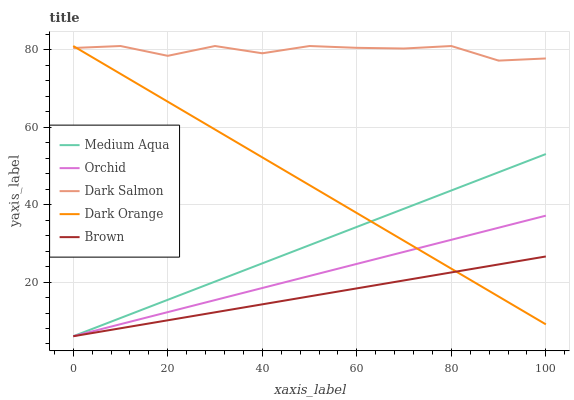Does Brown have the minimum area under the curve?
Answer yes or no. Yes. Does Dark Salmon have the maximum area under the curve?
Answer yes or no. Yes. Does Medium Aqua have the minimum area under the curve?
Answer yes or no. No. Does Medium Aqua have the maximum area under the curve?
Answer yes or no. No. Is Brown the smoothest?
Answer yes or no. Yes. Is Dark Salmon the roughest?
Answer yes or no. Yes. Is Medium Aqua the smoothest?
Answer yes or no. No. Is Medium Aqua the roughest?
Answer yes or no. No. Does Medium Aqua have the lowest value?
Answer yes or no. Yes. Does Dark Salmon have the lowest value?
Answer yes or no. No. Does Dark Salmon have the highest value?
Answer yes or no. Yes. Does Medium Aqua have the highest value?
Answer yes or no. No. Is Medium Aqua less than Dark Salmon?
Answer yes or no. Yes. Is Dark Salmon greater than Brown?
Answer yes or no. Yes. Does Brown intersect Dark Orange?
Answer yes or no. Yes. Is Brown less than Dark Orange?
Answer yes or no. No. Is Brown greater than Dark Orange?
Answer yes or no. No. Does Medium Aqua intersect Dark Salmon?
Answer yes or no. No. 